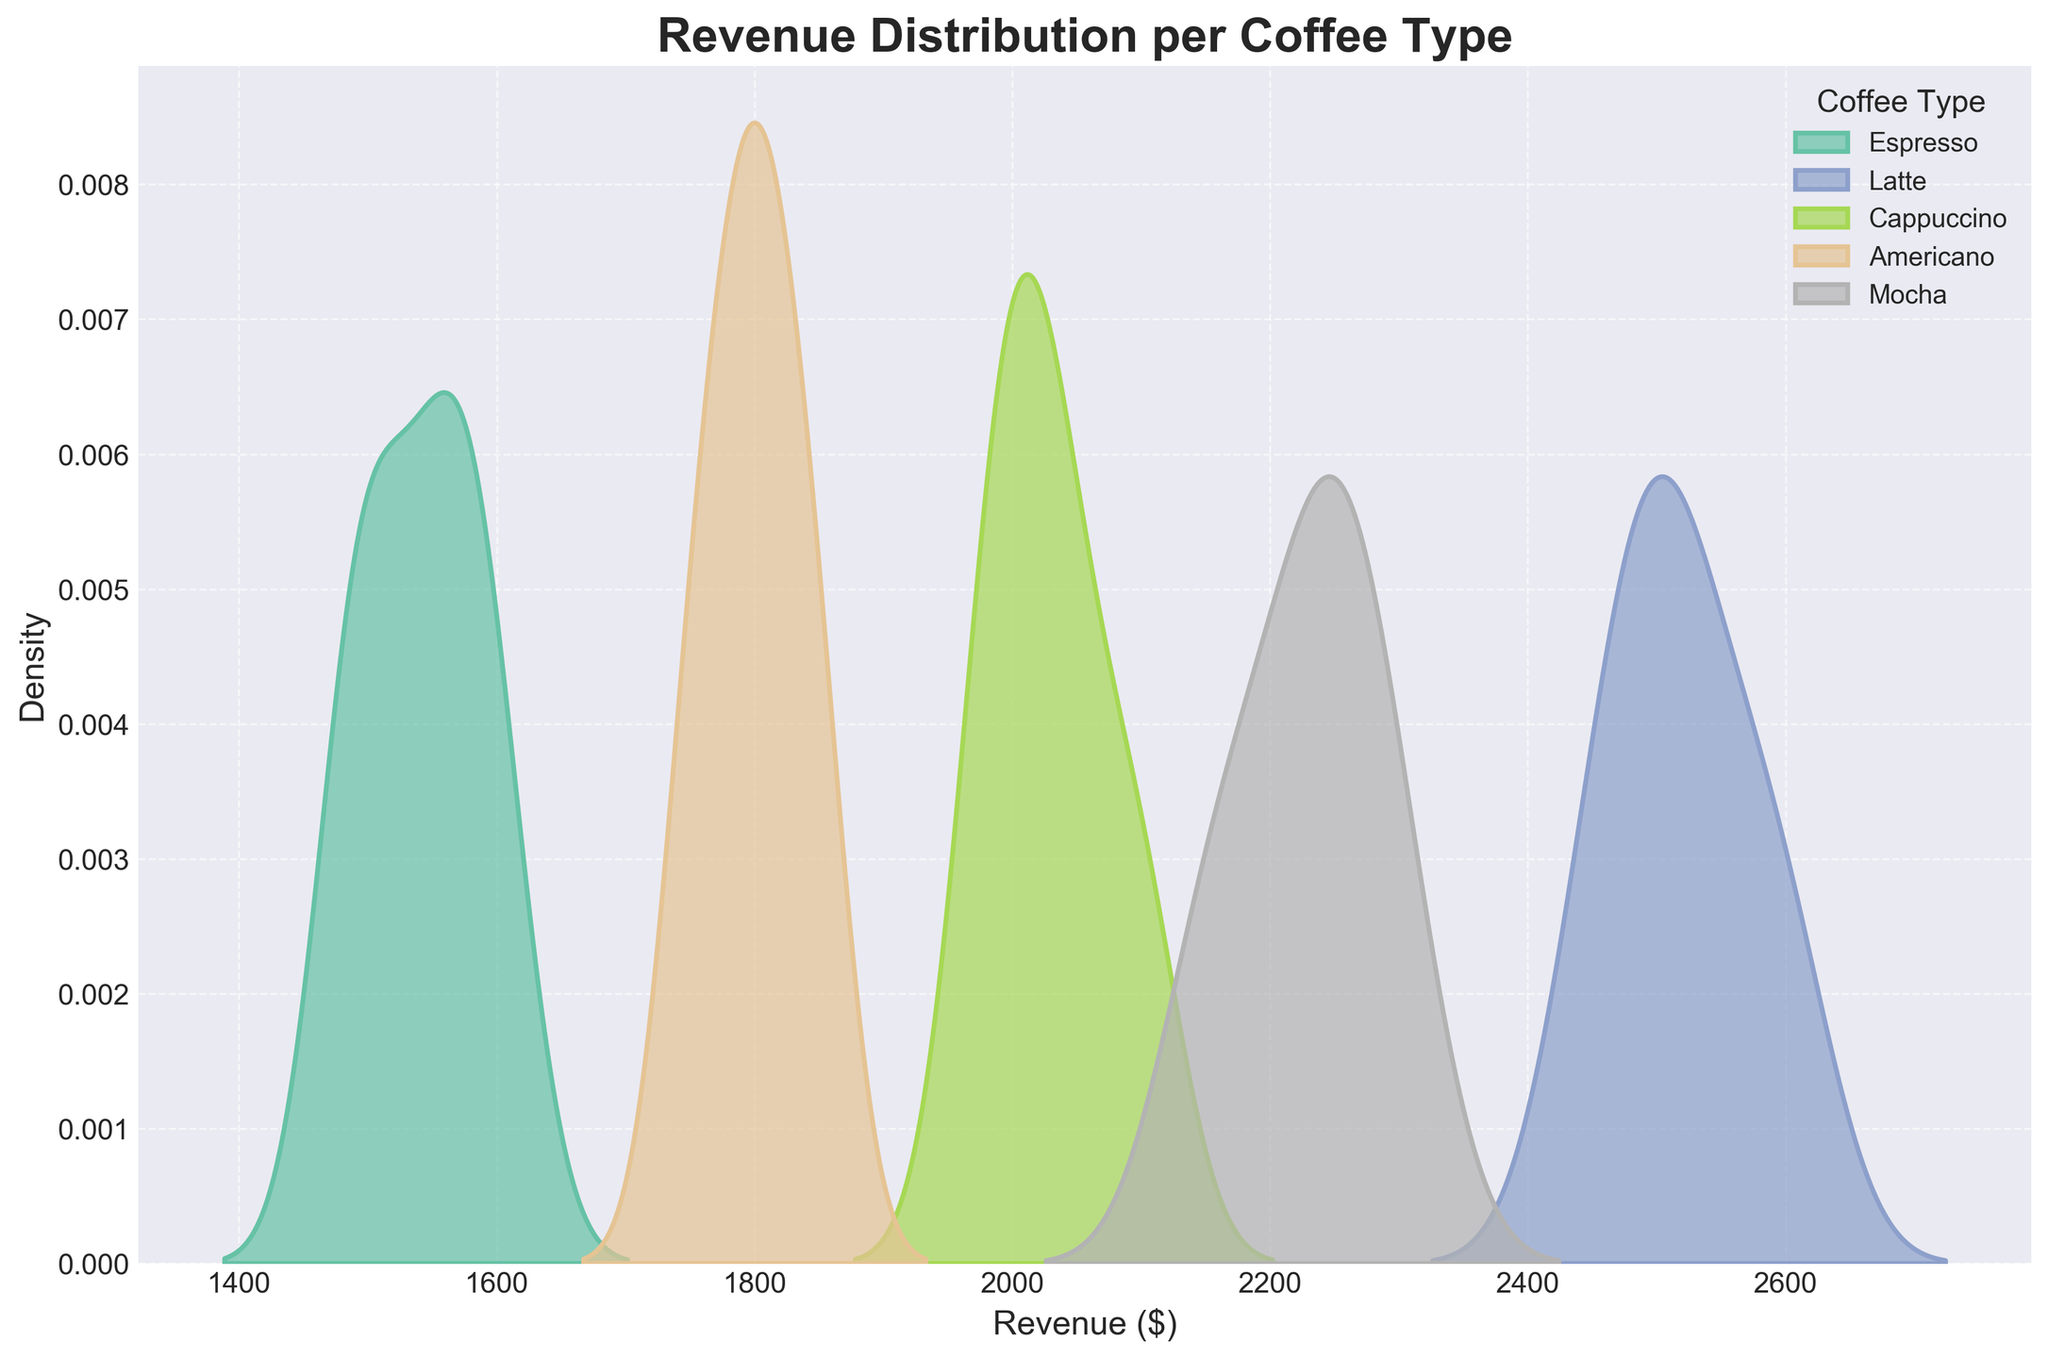What is the title of the plot? The title is displayed at the top of the figure.
Answer: Revenue Distribution per Coffee Type What does the x-axis represent? The x-axis is labeled as "Revenue ($)," indicating it represents the revenue in dollars.
Answer: Revenue ($) What color is used to represent the Cappuccino revenue distribution? By observing the plot legend, the color associated with Cappuccino can be identified.
Answer: The specific color used Which coffee type has the highest peak in density? Looking at the plot, identify the density curve that reaches the highest point on the y-axis.
Answer: Latte How do the revenue distributions of Espresso and Mocha compare? Compare the locations and shapes of the density curves for Espresso and Mocha. Espresso's curve is more to the left (lower revenue) compared to Mocha's curve, which is more to the right (higher revenue).
Answer: Espresso has lower revenue than Mocha What is the approximate range of revenue for the Americano type? Determine the spread of the density curve for Americano on the x-axis, noting the revenue values at the start and end of the curve.
Answer: Approximately $1750 to $1850 Which coffee type shows the widest revenue distribution? Identify the density curve with the widest spread on the x-axis. The curve for Latte appears to be spread over a wider range of revenue values compared to other types.
Answer: Latte Are there any coffee types with overlapping revenue distributions? If so, which ones? Look at where the density curves overlap. The density plots of Latte and Mocha overlap significantly, indicating they have similar revenue distributions.
Answer: Latte and Mocha What can you infer from the fact that the density curve for Espresso is the narrowest? A narrow density curve indicates less variability in revenue. The Espresso revenue is tightly clustered around a specific range, suggesting consistent sales.
Answer: Consistent sales for Espresso 